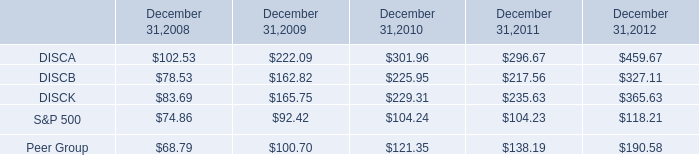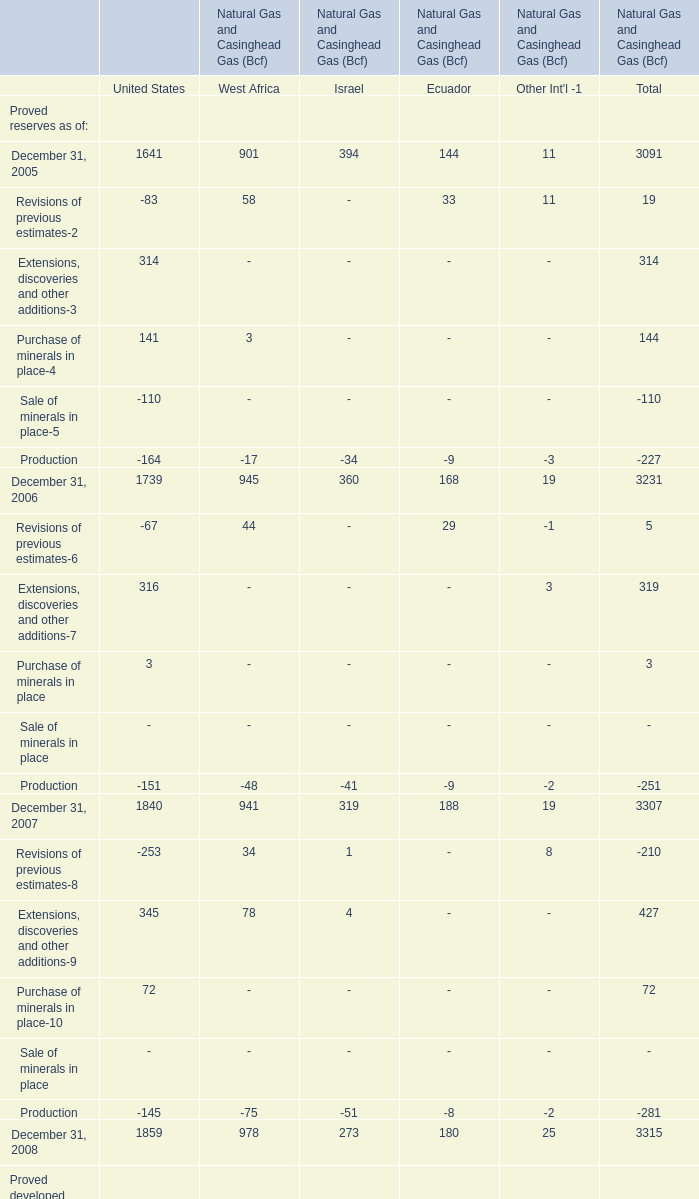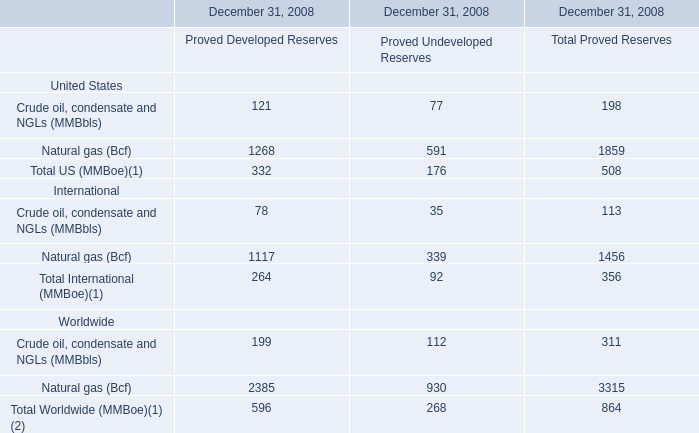what was the percentage cumulative total shareholder return on discb common stock from september 18 , 2008 to december 31 , 2012? 
Computations: ((327.11 - 100) / 100)
Answer: 2.2711. 